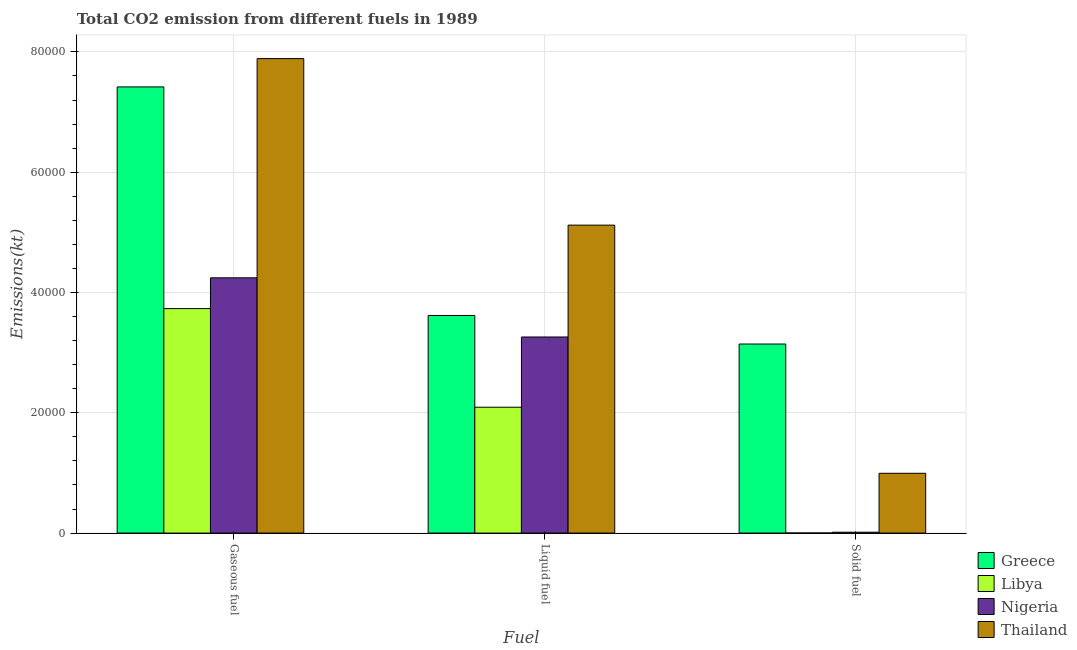How many different coloured bars are there?
Offer a terse response. 4. Are the number of bars per tick equal to the number of legend labels?
Your response must be concise. Yes. How many bars are there on the 1st tick from the left?
Offer a very short reply. 4. What is the label of the 3rd group of bars from the left?
Offer a very short reply. Solid fuel. What is the amount of co2 emissions from gaseous fuel in Libya?
Your answer should be compact. 3.73e+04. Across all countries, what is the maximum amount of co2 emissions from solid fuel?
Your answer should be compact. 3.14e+04. Across all countries, what is the minimum amount of co2 emissions from liquid fuel?
Provide a short and direct response. 2.09e+04. In which country was the amount of co2 emissions from gaseous fuel maximum?
Make the answer very short. Thailand. In which country was the amount of co2 emissions from solid fuel minimum?
Give a very brief answer. Libya. What is the total amount of co2 emissions from gaseous fuel in the graph?
Your answer should be compact. 2.33e+05. What is the difference between the amount of co2 emissions from gaseous fuel in Libya and that in Greece?
Your answer should be very brief. -3.69e+04. What is the difference between the amount of co2 emissions from gaseous fuel in Thailand and the amount of co2 emissions from liquid fuel in Libya?
Provide a short and direct response. 5.80e+04. What is the average amount of co2 emissions from solid fuel per country?
Offer a terse response. 1.04e+04. What is the difference between the amount of co2 emissions from solid fuel and amount of co2 emissions from liquid fuel in Greece?
Your answer should be very brief. -4748.76. In how many countries, is the amount of co2 emissions from solid fuel greater than 20000 kt?
Keep it short and to the point. 1. What is the ratio of the amount of co2 emissions from solid fuel in Greece to that in Thailand?
Ensure brevity in your answer.  3.16. Is the difference between the amount of co2 emissions from gaseous fuel in Greece and Libya greater than the difference between the amount of co2 emissions from solid fuel in Greece and Libya?
Provide a succinct answer. Yes. What is the difference between the highest and the second highest amount of co2 emissions from solid fuel?
Your answer should be very brief. 2.15e+04. What is the difference between the highest and the lowest amount of co2 emissions from liquid fuel?
Make the answer very short. 3.03e+04. Is it the case that in every country, the sum of the amount of co2 emissions from gaseous fuel and amount of co2 emissions from liquid fuel is greater than the amount of co2 emissions from solid fuel?
Provide a short and direct response. Yes. How many bars are there?
Make the answer very short. 12. Are all the bars in the graph horizontal?
Keep it short and to the point. No. How many countries are there in the graph?
Your response must be concise. 4. Are the values on the major ticks of Y-axis written in scientific E-notation?
Make the answer very short. No. Does the graph contain any zero values?
Give a very brief answer. No. How many legend labels are there?
Your response must be concise. 4. How are the legend labels stacked?
Your response must be concise. Vertical. What is the title of the graph?
Offer a very short reply. Total CO2 emission from different fuels in 1989. What is the label or title of the X-axis?
Give a very brief answer. Fuel. What is the label or title of the Y-axis?
Provide a succinct answer. Emissions(kt). What is the Emissions(kt) in Greece in Gaseous fuel?
Provide a succinct answer. 7.42e+04. What is the Emissions(kt) in Libya in Gaseous fuel?
Offer a very short reply. 3.73e+04. What is the Emissions(kt) of Nigeria in Gaseous fuel?
Provide a short and direct response. 4.24e+04. What is the Emissions(kt) in Thailand in Gaseous fuel?
Your answer should be very brief. 7.89e+04. What is the Emissions(kt) of Greece in Liquid fuel?
Your answer should be very brief. 3.62e+04. What is the Emissions(kt) in Libya in Liquid fuel?
Provide a succinct answer. 2.09e+04. What is the Emissions(kt) of Nigeria in Liquid fuel?
Provide a succinct answer. 3.26e+04. What is the Emissions(kt) in Thailand in Liquid fuel?
Your response must be concise. 5.12e+04. What is the Emissions(kt) of Greece in Solid fuel?
Offer a terse response. 3.14e+04. What is the Emissions(kt) of Libya in Solid fuel?
Make the answer very short. 11. What is the Emissions(kt) of Nigeria in Solid fuel?
Offer a terse response. 143.01. What is the Emissions(kt) in Thailand in Solid fuel?
Keep it short and to the point. 9941.24. Across all Fuel, what is the maximum Emissions(kt) of Greece?
Offer a very short reply. 7.42e+04. Across all Fuel, what is the maximum Emissions(kt) of Libya?
Offer a terse response. 3.73e+04. Across all Fuel, what is the maximum Emissions(kt) in Nigeria?
Provide a short and direct response. 4.24e+04. Across all Fuel, what is the maximum Emissions(kt) in Thailand?
Provide a succinct answer. 7.89e+04. Across all Fuel, what is the minimum Emissions(kt) in Greece?
Your answer should be compact. 3.14e+04. Across all Fuel, what is the minimum Emissions(kt) in Libya?
Offer a terse response. 11. Across all Fuel, what is the minimum Emissions(kt) in Nigeria?
Provide a short and direct response. 143.01. Across all Fuel, what is the minimum Emissions(kt) in Thailand?
Make the answer very short. 9941.24. What is the total Emissions(kt) of Greece in the graph?
Your response must be concise. 1.42e+05. What is the total Emissions(kt) of Libya in the graph?
Provide a succinct answer. 5.83e+04. What is the total Emissions(kt) in Nigeria in the graph?
Offer a terse response. 7.52e+04. What is the total Emissions(kt) in Thailand in the graph?
Keep it short and to the point. 1.40e+05. What is the difference between the Emissions(kt) of Greece in Gaseous fuel and that in Liquid fuel?
Offer a terse response. 3.80e+04. What is the difference between the Emissions(kt) in Libya in Gaseous fuel and that in Liquid fuel?
Your answer should be compact. 1.64e+04. What is the difference between the Emissions(kt) in Nigeria in Gaseous fuel and that in Liquid fuel?
Provide a succinct answer. 9838.56. What is the difference between the Emissions(kt) of Thailand in Gaseous fuel and that in Liquid fuel?
Make the answer very short. 2.77e+04. What is the difference between the Emissions(kt) in Greece in Gaseous fuel and that in Solid fuel?
Offer a terse response. 4.27e+04. What is the difference between the Emissions(kt) of Libya in Gaseous fuel and that in Solid fuel?
Ensure brevity in your answer.  3.73e+04. What is the difference between the Emissions(kt) in Nigeria in Gaseous fuel and that in Solid fuel?
Your answer should be compact. 4.23e+04. What is the difference between the Emissions(kt) of Thailand in Gaseous fuel and that in Solid fuel?
Offer a terse response. 6.90e+04. What is the difference between the Emissions(kt) of Greece in Liquid fuel and that in Solid fuel?
Give a very brief answer. 4748.77. What is the difference between the Emissions(kt) of Libya in Liquid fuel and that in Solid fuel?
Keep it short and to the point. 2.09e+04. What is the difference between the Emissions(kt) in Nigeria in Liquid fuel and that in Solid fuel?
Offer a very short reply. 3.25e+04. What is the difference between the Emissions(kt) in Thailand in Liquid fuel and that in Solid fuel?
Ensure brevity in your answer.  4.13e+04. What is the difference between the Emissions(kt) of Greece in Gaseous fuel and the Emissions(kt) of Libya in Liquid fuel?
Your answer should be very brief. 5.33e+04. What is the difference between the Emissions(kt) in Greece in Gaseous fuel and the Emissions(kt) in Nigeria in Liquid fuel?
Offer a terse response. 4.16e+04. What is the difference between the Emissions(kt) of Greece in Gaseous fuel and the Emissions(kt) of Thailand in Liquid fuel?
Offer a very short reply. 2.30e+04. What is the difference between the Emissions(kt) of Libya in Gaseous fuel and the Emissions(kt) of Nigeria in Liquid fuel?
Make the answer very short. 4719.43. What is the difference between the Emissions(kt) of Libya in Gaseous fuel and the Emissions(kt) of Thailand in Liquid fuel?
Provide a short and direct response. -1.39e+04. What is the difference between the Emissions(kt) of Nigeria in Gaseous fuel and the Emissions(kt) of Thailand in Liquid fuel?
Offer a terse response. -8760.46. What is the difference between the Emissions(kt) of Greece in Gaseous fuel and the Emissions(kt) of Libya in Solid fuel?
Make the answer very short. 7.42e+04. What is the difference between the Emissions(kt) of Greece in Gaseous fuel and the Emissions(kt) of Nigeria in Solid fuel?
Offer a very short reply. 7.40e+04. What is the difference between the Emissions(kt) of Greece in Gaseous fuel and the Emissions(kt) of Thailand in Solid fuel?
Offer a terse response. 6.42e+04. What is the difference between the Emissions(kt) of Libya in Gaseous fuel and the Emissions(kt) of Nigeria in Solid fuel?
Provide a short and direct response. 3.72e+04. What is the difference between the Emissions(kt) in Libya in Gaseous fuel and the Emissions(kt) in Thailand in Solid fuel?
Give a very brief answer. 2.74e+04. What is the difference between the Emissions(kt) of Nigeria in Gaseous fuel and the Emissions(kt) of Thailand in Solid fuel?
Your answer should be very brief. 3.25e+04. What is the difference between the Emissions(kt) in Greece in Liquid fuel and the Emissions(kt) in Libya in Solid fuel?
Ensure brevity in your answer.  3.62e+04. What is the difference between the Emissions(kt) in Greece in Liquid fuel and the Emissions(kt) in Nigeria in Solid fuel?
Your answer should be compact. 3.60e+04. What is the difference between the Emissions(kt) in Greece in Liquid fuel and the Emissions(kt) in Thailand in Solid fuel?
Offer a very short reply. 2.62e+04. What is the difference between the Emissions(kt) in Libya in Liquid fuel and the Emissions(kt) in Nigeria in Solid fuel?
Give a very brief answer. 2.08e+04. What is the difference between the Emissions(kt) in Libya in Liquid fuel and the Emissions(kt) in Thailand in Solid fuel?
Provide a short and direct response. 1.10e+04. What is the difference between the Emissions(kt) in Nigeria in Liquid fuel and the Emissions(kt) in Thailand in Solid fuel?
Provide a short and direct response. 2.27e+04. What is the average Emissions(kt) in Greece per Fuel?
Provide a succinct answer. 4.73e+04. What is the average Emissions(kt) in Libya per Fuel?
Make the answer very short. 1.94e+04. What is the average Emissions(kt) in Nigeria per Fuel?
Make the answer very short. 2.51e+04. What is the average Emissions(kt) of Thailand per Fuel?
Make the answer very short. 4.67e+04. What is the difference between the Emissions(kt) of Greece and Emissions(kt) of Libya in Gaseous fuel?
Keep it short and to the point. 3.69e+04. What is the difference between the Emissions(kt) of Greece and Emissions(kt) of Nigeria in Gaseous fuel?
Give a very brief answer. 3.17e+04. What is the difference between the Emissions(kt) in Greece and Emissions(kt) in Thailand in Gaseous fuel?
Ensure brevity in your answer.  -4708.43. What is the difference between the Emissions(kt) in Libya and Emissions(kt) in Nigeria in Gaseous fuel?
Your answer should be compact. -5119.13. What is the difference between the Emissions(kt) of Libya and Emissions(kt) of Thailand in Gaseous fuel?
Ensure brevity in your answer.  -4.16e+04. What is the difference between the Emissions(kt) in Nigeria and Emissions(kt) in Thailand in Gaseous fuel?
Your answer should be compact. -3.64e+04. What is the difference between the Emissions(kt) in Greece and Emissions(kt) in Libya in Liquid fuel?
Offer a terse response. 1.53e+04. What is the difference between the Emissions(kt) in Greece and Emissions(kt) in Nigeria in Liquid fuel?
Ensure brevity in your answer.  3578.99. What is the difference between the Emissions(kt) in Greece and Emissions(kt) in Thailand in Liquid fuel?
Make the answer very short. -1.50e+04. What is the difference between the Emissions(kt) in Libya and Emissions(kt) in Nigeria in Liquid fuel?
Keep it short and to the point. -1.17e+04. What is the difference between the Emissions(kt) in Libya and Emissions(kt) in Thailand in Liquid fuel?
Make the answer very short. -3.03e+04. What is the difference between the Emissions(kt) of Nigeria and Emissions(kt) of Thailand in Liquid fuel?
Make the answer very short. -1.86e+04. What is the difference between the Emissions(kt) of Greece and Emissions(kt) of Libya in Solid fuel?
Make the answer very short. 3.14e+04. What is the difference between the Emissions(kt) in Greece and Emissions(kt) in Nigeria in Solid fuel?
Ensure brevity in your answer.  3.13e+04. What is the difference between the Emissions(kt) in Greece and Emissions(kt) in Thailand in Solid fuel?
Offer a very short reply. 2.15e+04. What is the difference between the Emissions(kt) in Libya and Emissions(kt) in Nigeria in Solid fuel?
Your answer should be compact. -132.01. What is the difference between the Emissions(kt) in Libya and Emissions(kt) in Thailand in Solid fuel?
Keep it short and to the point. -9930.24. What is the difference between the Emissions(kt) of Nigeria and Emissions(kt) of Thailand in Solid fuel?
Your answer should be compact. -9798.22. What is the ratio of the Emissions(kt) of Greece in Gaseous fuel to that in Liquid fuel?
Your response must be concise. 2.05. What is the ratio of the Emissions(kt) in Libya in Gaseous fuel to that in Liquid fuel?
Give a very brief answer. 1.78. What is the ratio of the Emissions(kt) in Nigeria in Gaseous fuel to that in Liquid fuel?
Provide a succinct answer. 1.3. What is the ratio of the Emissions(kt) in Thailand in Gaseous fuel to that in Liquid fuel?
Provide a succinct answer. 1.54. What is the ratio of the Emissions(kt) of Greece in Gaseous fuel to that in Solid fuel?
Offer a terse response. 2.36. What is the ratio of the Emissions(kt) in Libya in Gaseous fuel to that in Solid fuel?
Your answer should be very brief. 3392.67. What is the ratio of the Emissions(kt) of Nigeria in Gaseous fuel to that in Solid fuel?
Your answer should be compact. 296.77. What is the ratio of the Emissions(kt) in Thailand in Gaseous fuel to that in Solid fuel?
Offer a very short reply. 7.94. What is the ratio of the Emissions(kt) in Greece in Liquid fuel to that in Solid fuel?
Keep it short and to the point. 1.15. What is the ratio of the Emissions(kt) in Libya in Liquid fuel to that in Solid fuel?
Ensure brevity in your answer.  1902. What is the ratio of the Emissions(kt) in Nigeria in Liquid fuel to that in Solid fuel?
Provide a succinct answer. 227.97. What is the ratio of the Emissions(kt) in Thailand in Liquid fuel to that in Solid fuel?
Ensure brevity in your answer.  5.15. What is the difference between the highest and the second highest Emissions(kt) of Greece?
Keep it short and to the point. 3.80e+04. What is the difference between the highest and the second highest Emissions(kt) of Libya?
Make the answer very short. 1.64e+04. What is the difference between the highest and the second highest Emissions(kt) in Nigeria?
Provide a short and direct response. 9838.56. What is the difference between the highest and the second highest Emissions(kt) in Thailand?
Provide a short and direct response. 2.77e+04. What is the difference between the highest and the lowest Emissions(kt) in Greece?
Keep it short and to the point. 4.27e+04. What is the difference between the highest and the lowest Emissions(kt) of Libya?
Make the answer very short. 3.73e+04. What is the difference between the highest and the lowest Emissions(kt) of Nigeria?
Your answer should be very brief. 4.23e+04. What is the difference between the highest and the lowest Emissions(kt) of Thailand?
Keep it short and to the point. 6.90e+04. 